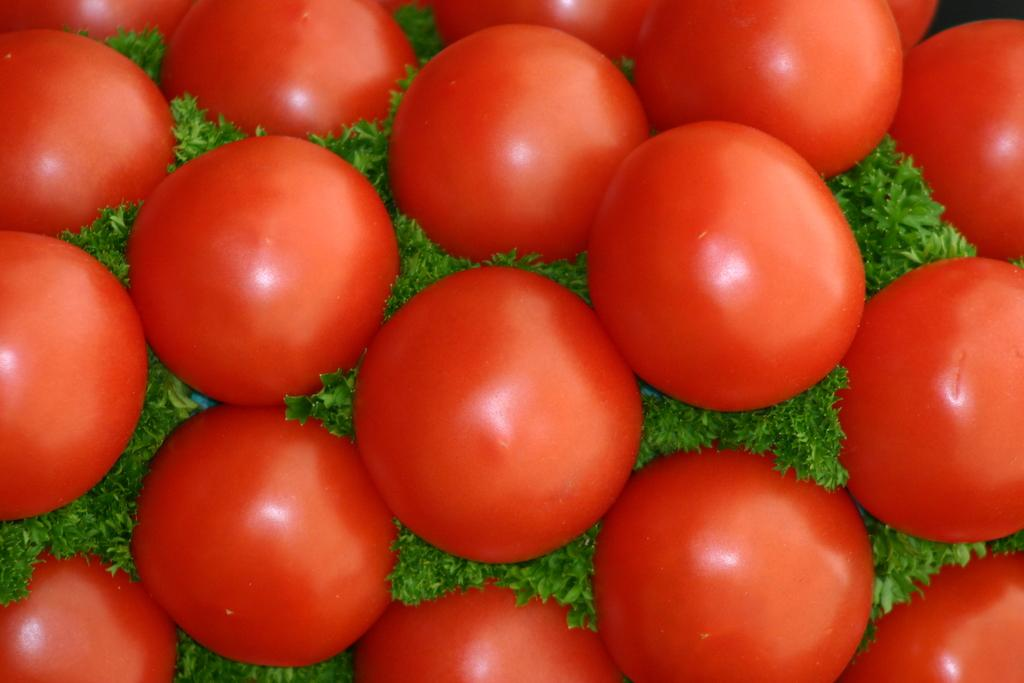What type of fruit can be seen in the image? There are tomatoes in the image. What else is present in the image besides the tomatoes? There are leaves in the image. What color is the silver wing on the tomato plant in the image? There is no silver wing present in the image; it only features tomatoes and leaves. 